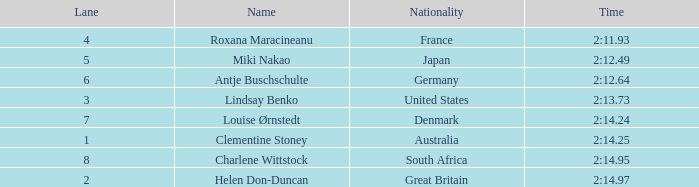For louise ørnstedt, what is the quantity of lanes possessing a rank exceeding 2? 1.0. 